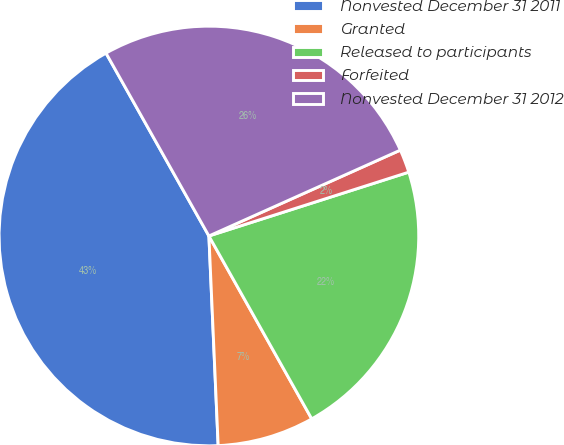Convert chart. <chart><loc_0><loc_0><loc_500><loc_500><pie_chart><fcel>Nonvested December 31 2011<fcel>Granted<fcel>Released to participants<fcel>Forfeited<fcel>Nonvested December 31 2012<nl><fcel>42.55%<fcel>7.45%<fcel>21.77%<fcel>1.79%<fcel>26.45%<nl></chart> 